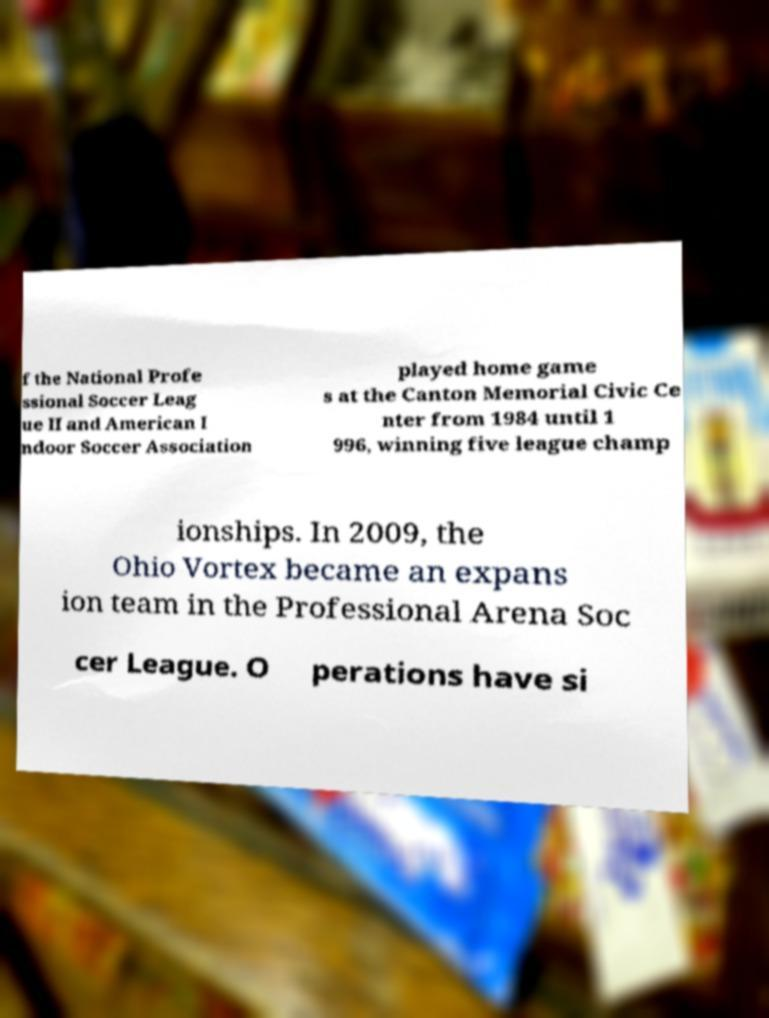What messages or text are displayed in this image? I need them in a readable, typed format. f the National Profe ssional Soccer Leag ue II and American I ndoor Soccer Association played home game s at the Canton Memorial Civic Ce nter from 1984 until 1 996, winning five league champ ionships. In 2009, the Ohio Vortex became an expans ion team in the Professional Arena Soc cer League. O perations have si 